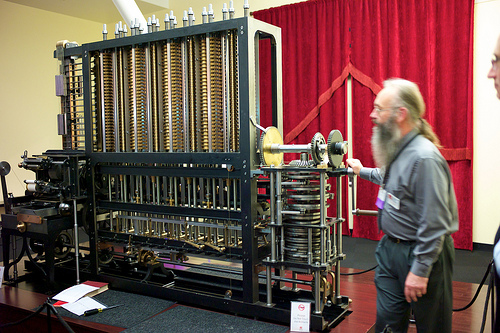<image>
Is the curtain behind the machine? Yes. From this viewpoint, the curtain is positioned behind the machine, with the machine partially or fully occluding the curtain. 